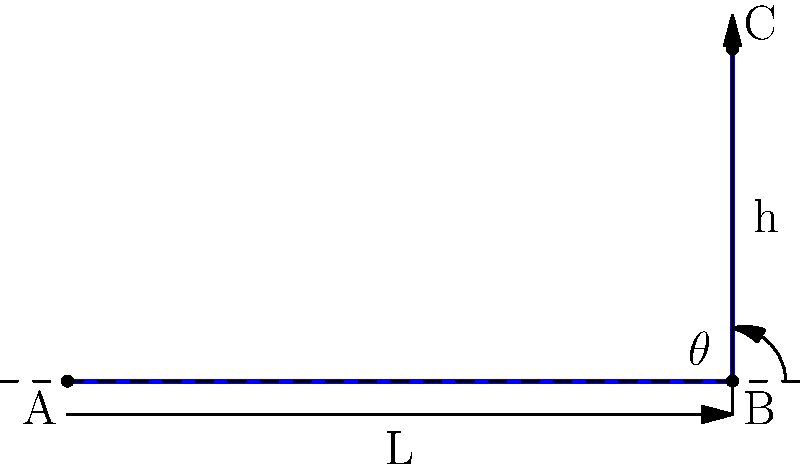As a baggage handler trainee, you're tasked with optimizing a conveyor belt system. The belt runs from point A to C, passing through point B. If the horizontal distance (L) is 10 meters and the vertical height (h) is 5 meters, what is the optimal angle $\theta$ for the inclined section BC to maximize baggage flow, assuming the coefficient of friction between the baggage and the belt is 0.3? To find the optimal angle for maximizing baggage flow, we need to consider the balance between gravity and friction. The optimal angle occurs when the component of gravity parallel to the belt just overcomes the friction force.

Step 1: Express the forces acting on the baggage.
- Gravity force: $F_g = mg$ (where $m$ is mass and $g$ is acceleration due to gravity)
- Normal force: $F_N = mg \cos \theta$
- Friction force: $F_f = \mu F_N = \mu mg \cos \theta$ (where $\mu$ is the coefficient of friction)

Step 2: Find the component of gravity parallel to the belt.
$F_{g\parallel} = mg \sin \theta$

Step 3: Set up the equation for the optimal angle.
At the optimal angle, $F_{g\parallel} = F_f$
$mg \sin \theta = \mu mg \cos \theta$

Step 4: Simplify and solve for $\theta$.
$\sin \theta = \mu \cos \theta$
$\tan \theta = \mu$
$\theta = \arctan(\mu)$

Step 5: Calculate the optimal angle using the given coefficient of friction.
$\theta = \arctan(0.3)$

Step 6: Convert to degrees.
$\theta \approx 16.7°$

Step 7: Verify using the given dimensions.
$\tan \theta = \frac{h}{L} = \frac{5}{10} = 0.5$
$\theta = \arctan(0.5) \approx 26.6°$

The calculated optimal angle (16.7°) is less than the angle determined by the given dimensions (26.6°). This means the conveyor belt is steeper than optimal, and reducing the angle would improve baggage flow.
Answer: $16.7°$ 